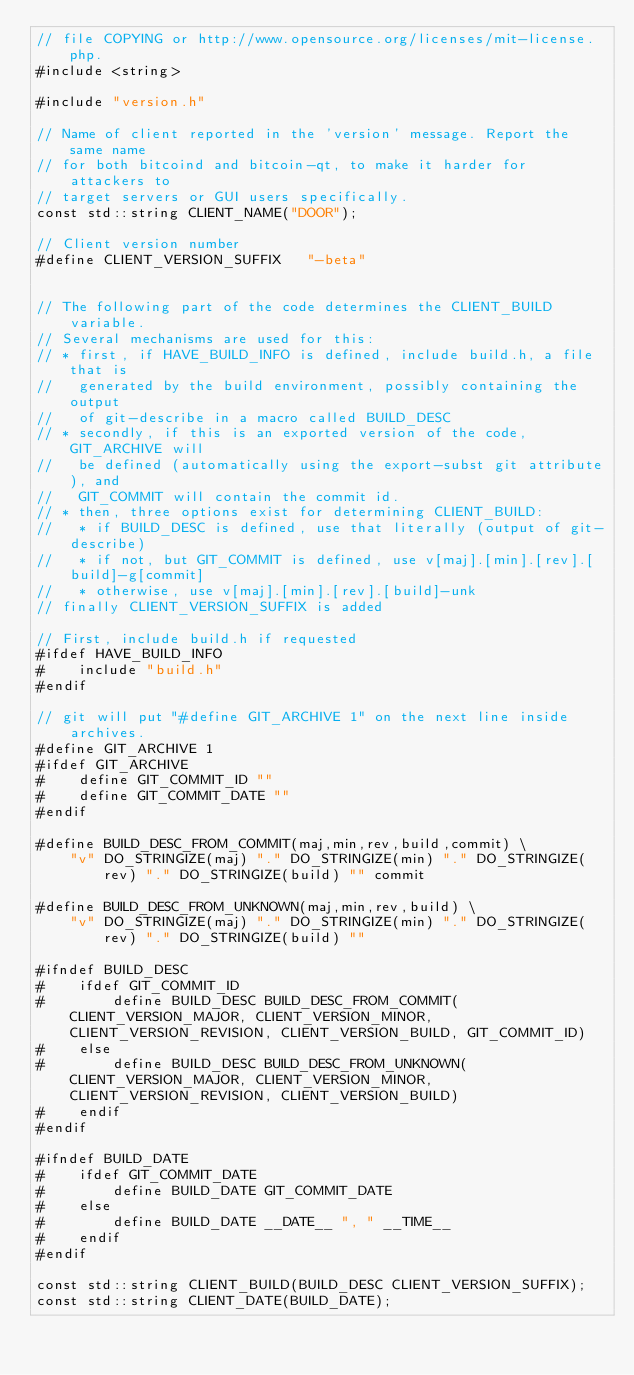Convert code to text. <code><loc_0><loc_0><loc_500><loc_500><_C++_>// file COPYING or http://www.opensource.org/licenses/mit-license.php.
#include <string>

#include "version.h"

// Name of client reported in the 'version' message. Report the same name
// for both bitcoind and bitcoin-qt, to make it harder for attackers to
// target servers or GUI users specifically.
const std::string CLIENT_NAME("DOOR");

// Client version number
#define CLIENT_VERSION_SUFFIX   "-beta"


// The following part of the code determines the CLIENT_BUILD variable.
// Several mechanisms are used for this:
// * first, if HAVE_BUILD_INFO is defined, include build.h, a file that is
//   generated by the build environment, possibly containing the output
//   of git-describe in a macro called BUILD_DESC
// * secondly, if this is an exported version of the code, GIT_ARCHIVE will
//   be defined (automatically using the export-subst git attribute), and
//   GIT_COMMIT will contain the commit id.
// * then, three options exist for determining CLIENT_BUILD:
//   * if BUILD_DESC is defined, use that literally (output of git-describe)
//   * if not, but GIT_COMMIT is defined, use v[maj].[min].[rev].[build]-g[commit]
//   * otherwise, use v[maj].[min].[rev].[build]-unk
// finally CLIENT_VERSION_SUFFIX is added

// First, include build.h if requested
#ifdef HAVE_BUILD_INFO
#    include "build.h"
#endif

// git will put "#define GIT_ARCHIVE 1" on the next line inside archives. 
#define GIT_ARCHIVE 1
#ifdef GIT_ARCHIVE
#    define GIT_COMMIT_ID ""
#    define GIT_COMMIT_DATE ""
#endif

#define BUILD_DESC_FROM_COMMIT(maj,min,rev,build,commit) \
    "v" DO_STRINGIZE(maj) "." DO_STRINGIZE(min) "." DO_STRINGIZE(rev) "." DO_STRINGIZE(build) "" commit

#define BUILD_DESC_FROM_UNKNOWN(maj,min,rev,build) \
    "v" DO_STRINGIZE(maj) "." DO_STRINGIZE(min) "." DO_STRINGIZE(rev) "." DO_STRINGIZE(build) ""

#ifndef BUILD_DESC
#    ifdef GIT_COMMIT_ID
#        define BUILD_DESC BUILD_DESC_FROM_COMMIT(CLIENT_VERSION_MAJOR, CLIENT_VERSION_MINOR, CLIENT_VERSION_REVISION, CLIENT_VERSION_BUILD, GIT_COMMIT_ID)
#    else
#        define BUILD_DESC BUILD_DESC_FROM_UNKNOWN(CLIENT_VERSION_MAJOR, CLIENT_VERSION_MINOR, CLIENT_VERSION_REVISION, CLIENT_VERSION_BUILD)
#    endif
#endif

#ifndef BUILD_DATE
#    ifdef GIT_COMMIT_DATE
#        define BUILD_DATE GIT_COMMIT_DATE
#    else
#        define BUILD_DATE __DATE__ ", " __TIME__
#    endif
#endif

const std::string CLIENT_BUILD(BUILD_DESC CLIENT_VERSION_SUFFIX);
const std::string CLIENT_DATE(BUILD_DATE);
</code> 